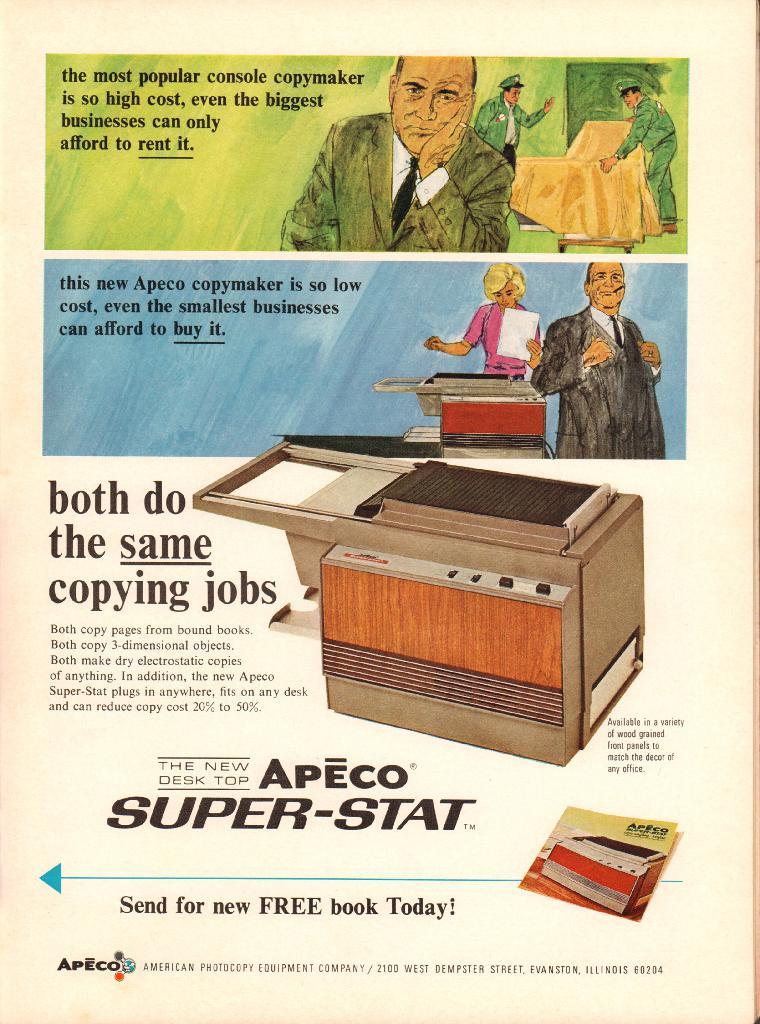What does it say we get for free?
Ensure brevity in your answer.  Book. What is the brand shown?
Your response must be concise. Apeco. 